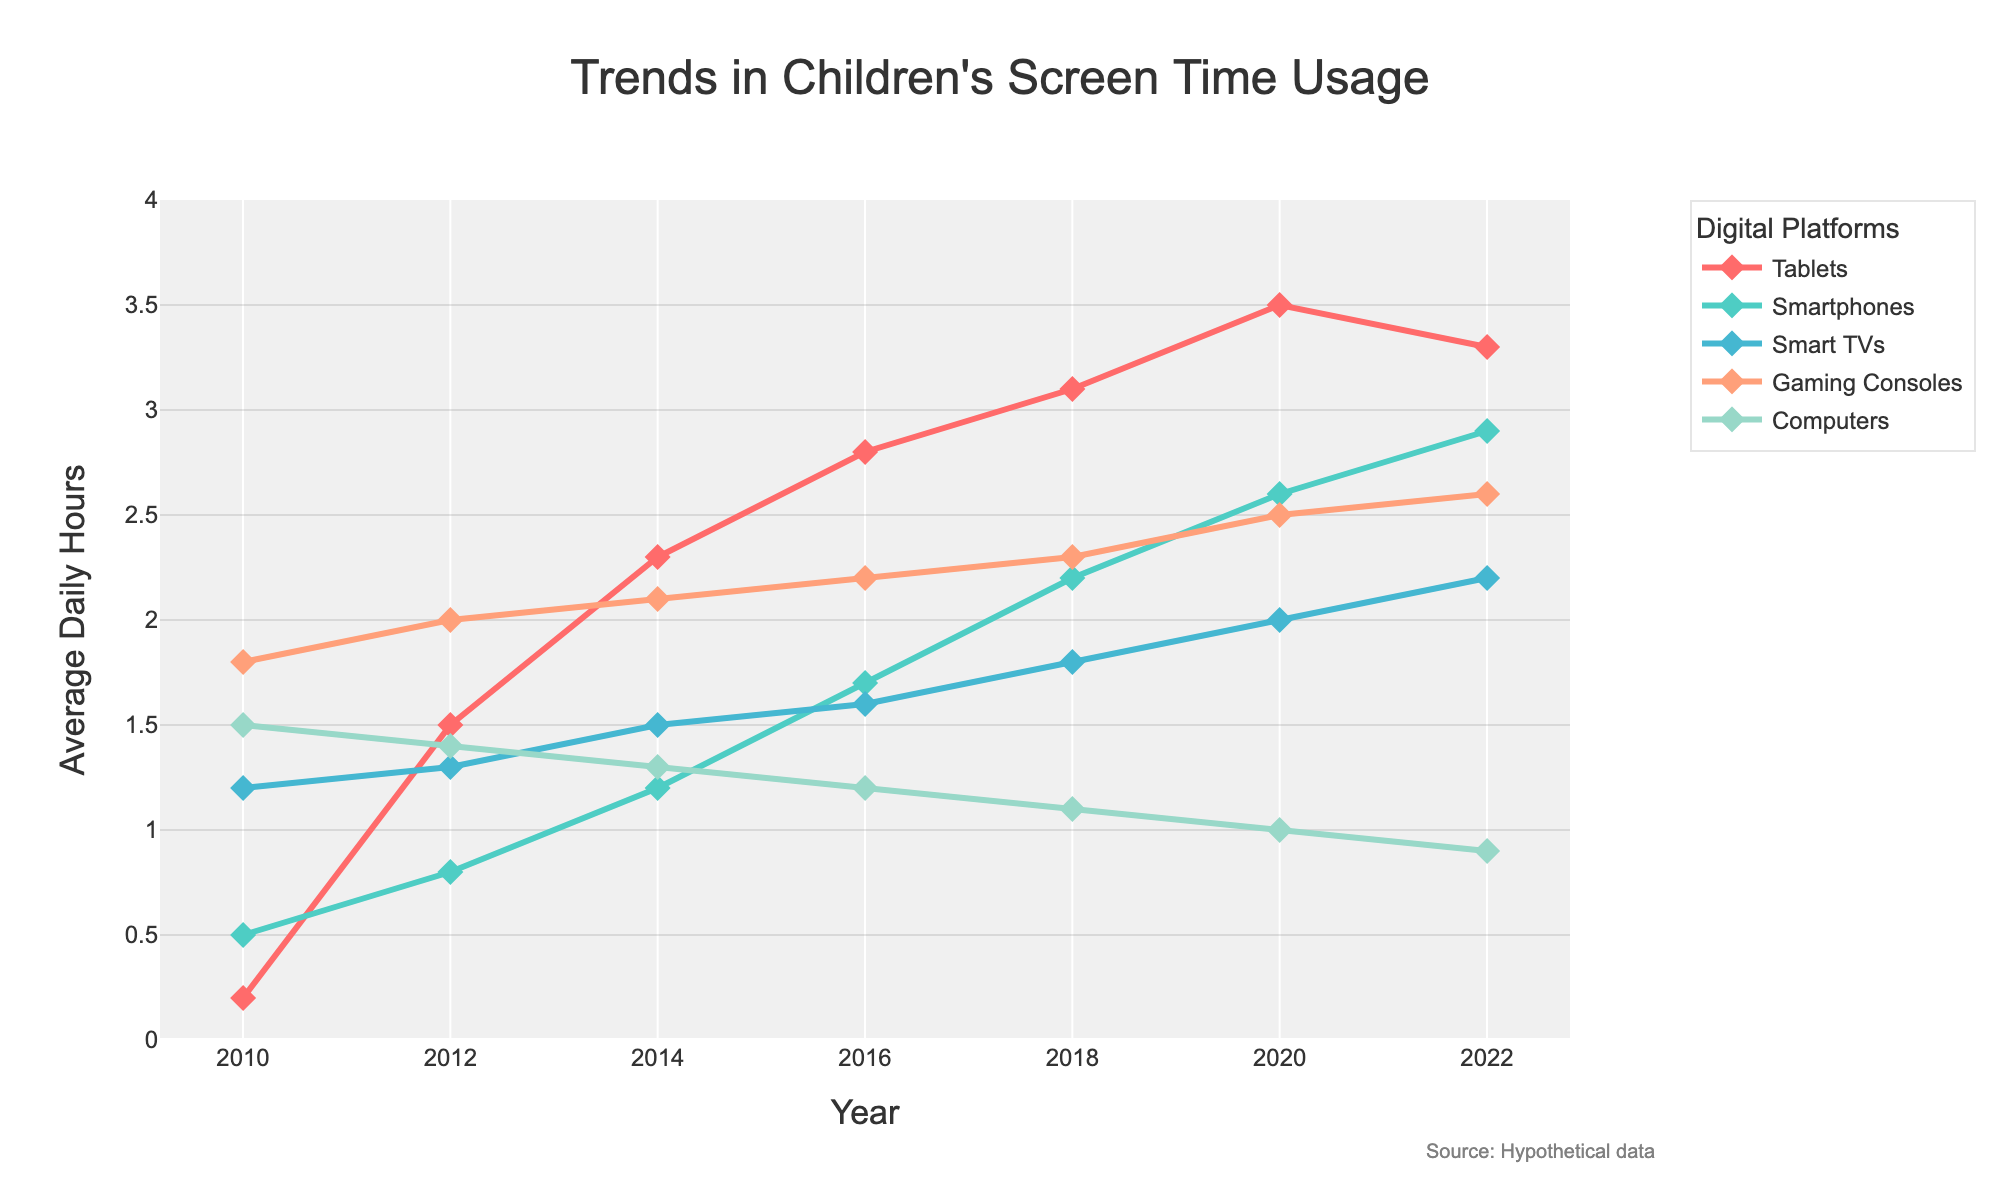What's the trend in tablet usage from 2010 to 2022? The tablet usage starts at 0.2 hours per day in 2010 and increases steadily each year, peaking at 3.5 hours per day in 2020. It then slightly declines to 3.3 hours per day in 2022.
Answer: Increasing with a peak in 2020 Which platform had the highest screen time in 2010 and what was it? In 2010, Smart TVs had the highest screen time with 1.2 hours per day. This can be observed by comparing the heights of the points on the chart for different platforms in 2010.
Answer: Smart TVs, 1.2 hours By how much did smartphone usage increase from 2010 to 2022? Smartphone usage increased from 0.5 hours per day in 2010 to 2.9 hours per day in 2022. The difference is calculated as 2.9 - 0.5 = 2.4 hours per day.
Answer: 2.4 hours Which platform showed a decreasing trend starting after 2020? Tablets showed a decreasing trend starting after 2020, where usage dropped from 3.5 hours per day in 2020 to 3.3 hours per day in 2022.
Answer: Tablets Among Gaming Consoles and Computers, which platform had a smaller variation in screen time from 2010 to 2022? Gaming Consoles varied from 1.8 to 2.6 hours, showing a variation of 0.8 hours. Computers varied from 0.9 to 1.5 hours, showing a variation of 0.6 hours. Therefore, Computers had a smaller variation.
Answer: Computers What's the average daily screen time across all platforms in 2022? Add the 2022 values: Tablets (3.3) + Smartphones (2.9) + Smart TVs (2.2) + Gaming Consoles (2.6) + Computers (0.9). Sum = 11.9 hours. Divide by 5 platforms: 11.9 / 5 = 2.38 hours.
Answer: 2.38 hours Which platform had the largest increase in usage from 2010 to 2018? Calculate the increase for each platform from 2010 to 2018: Tablets (3.1-0.2 = 2.9), Smartphones (2.2-0.5 = 1.7), Smart TVs (1.8-1.2 = 0.6), Gaming Consoles (2.3-1.8 = 0.5), Computers (1.1-1.5 = -0.4). Tablets had the largest increase of 2.9 hours.
Answer: Tablets How did the usage trends of Gaming Consoles and Smart TVs compare from 2010 to 2022? Both platforms showed a gradual increase in usage over the years. Gaming Consoles went from 1.8 to 2.6 hours and Smart TVs from 1.2 to 2.2 hours. The trends are similar, but Gaming Consoles have a slightly more pronounced increase overall.
Answer: Similar, slight edge to Gaming Consoles What was the lowest screen time recorded for any platform throughout the years and which one was it? The lowest screen time recorded is 0.2 hours per day which was for Tablets in 2010. This can be observed by identifying the smallest value point in the dataset.
Answer: Tablets, 0.2 hours 